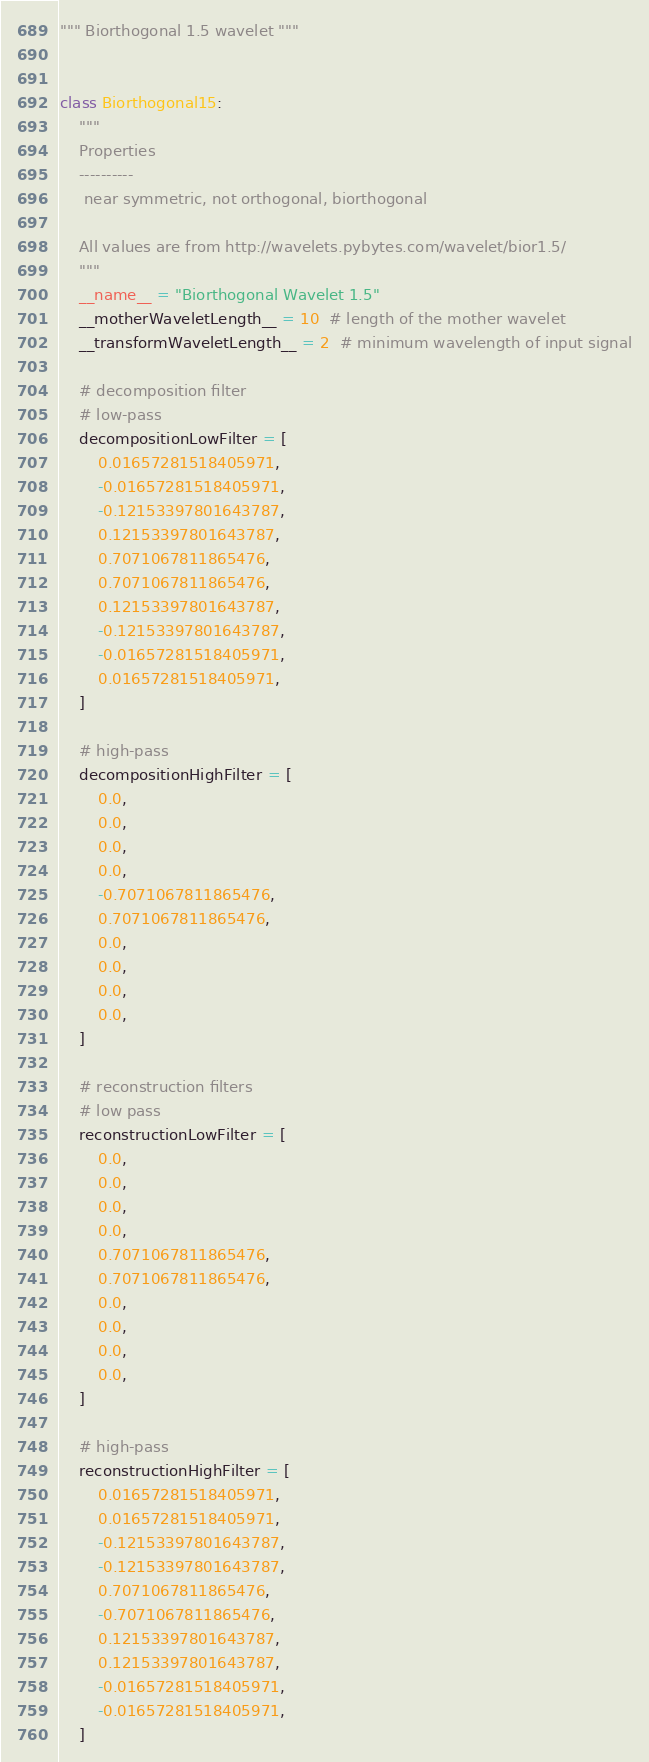Convert code to text. <code><loc_0><loc_0><loc_500><loc_500><_Python_>""" Biorthogonal 1.5 wavelet """


class Biorthogonal15:
    """
    Properties
    ----------
     near symmetric, not orthogonal, biorthogonal

    All values are from http://wavelets.pybytes.com/wavelet/bior1.5/
    """
    __name__ = "Biorthogonal Wavelet 1.5"
    __motherWaveletLength__ = 10  # length of the mother wavelet
    __transformWaveletLength__ = 2  # minimum wavelength of input signal

    # decomposition filter
    # low-pass
    decompositionLowFilter = [
        0.01657281518405971,
        -0.01657281518405971,
        -0.12153397801643787,
        0.12153397801643787,
        0.7071067811865476,
        0.7071067811865476,
        0.12153397801643787,
        -0.12153397801643787,
        -0.01657281518405971,
        0.01657281518405971,
    ]

    # high-pass
    decompositionHighFilter = [
        0.0,
        0.0,
        0.0,
        0.0,
        -0.7071067811865476,
        0.7071067811865476,
        0.0,
        0.0,
        0.0,
        0.0,
    ]

    # reconstruction filters
    # low pass
    reconstructionLowFilter = [
        0.0,
        0.0,
        0.0,
        0.0,
        0.7071067811865476,
        0.7071067811865476,
        0.0,
        0.0,
        0.0,
        0.0,
    ]

    # high-pass
    reconstructionHighFilter = [
        0.01657281518405971,
        0.01657281518405971,
        -0.12153397801643787,
        -0.12153397801643787,
        0.7071067811865476,
        -0.7071067811865476,
        0.12153397801643787,
        0.12153397801643787,
        -0.01657281518405971,
        -0.01657281518405971,
    ]
</code> 